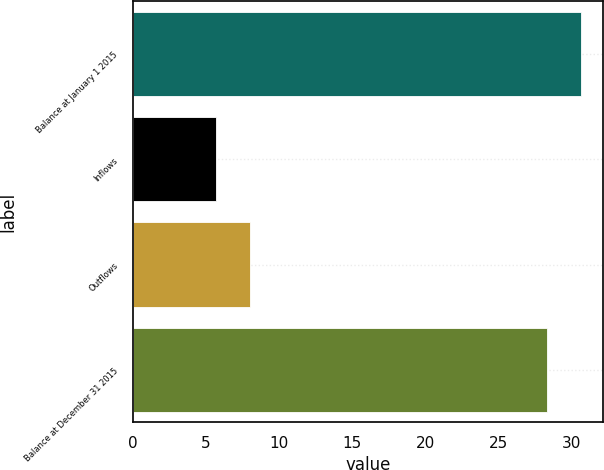Convert chart to OTSL. <chart><loc_0><loc_0><loc_500><loc_500><bar_chart><fcel>Balance at January 1 2015<fcel>Inflows<fcel>Outflows<fcel>Balance at December 31 2015<nl><fcel>30.61<fcel>5.7<fcel>8.01<fcel>28.3<nl></chart> 